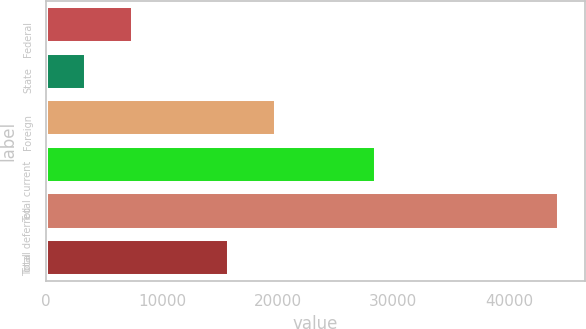<chart> <loc_0><loc_0><loc_500><loc_500><bar_chart><fcel>Federal<fcel>State<fcel>Foreign<fcel>Total current<fcel>Total deferred<fcel>Total<nl><fcel>7531.8<fcel>3442<fcel>19889.8<fcel>28540<fcel>44340<fcel>15800<nl></chart> 